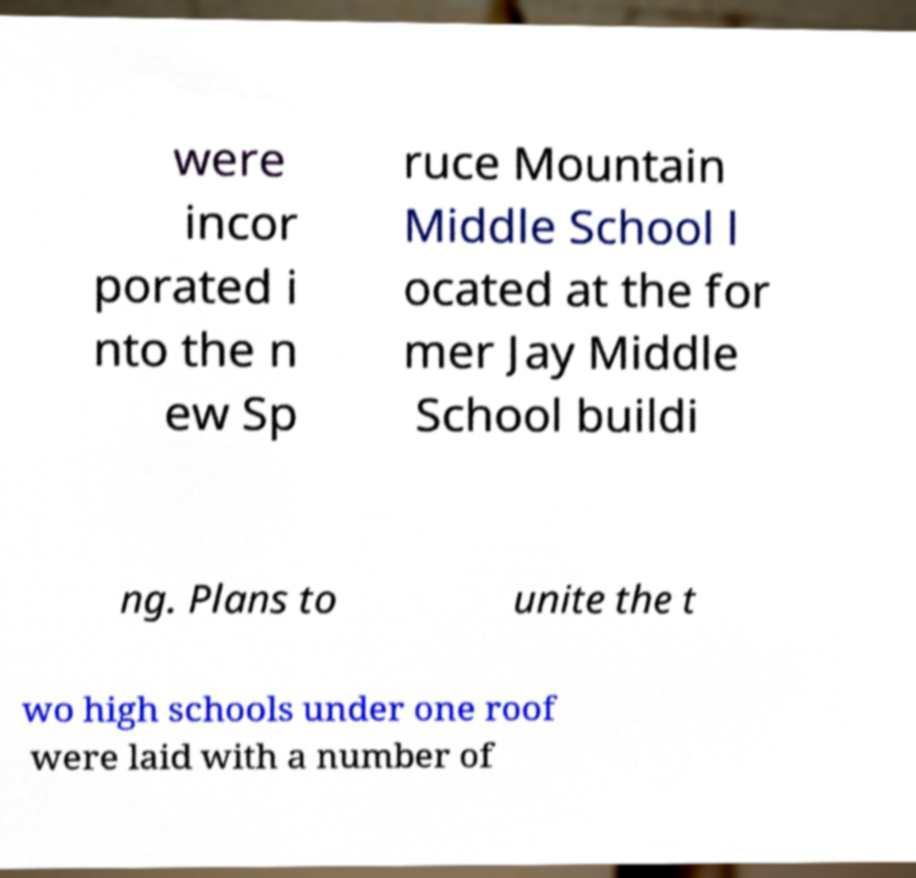For documentation purposes, I need the text within this image transcribed. Could you provide that? were incor porated i nto the n ew Sp ruce Mountain Middle School l ocated at the for mer Jay Middle School buildi ng. Plans to unite the t wo high schools under one roof were laid with a number of 